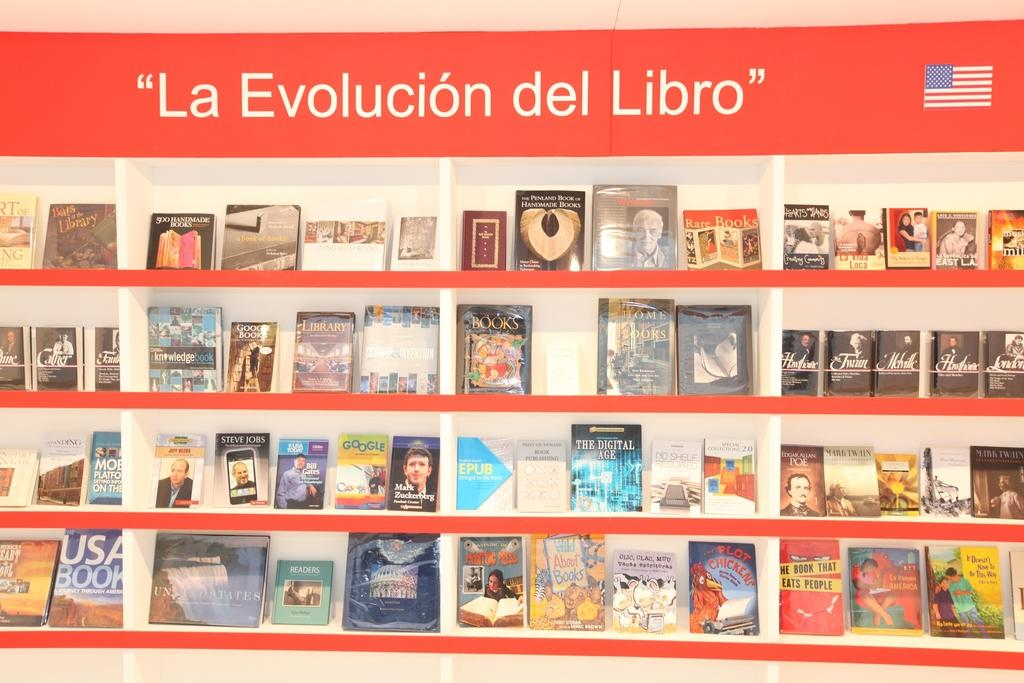<image>
Write a terse but informative summary of the picture. a book shelf with La Evolución de Libro written on top 